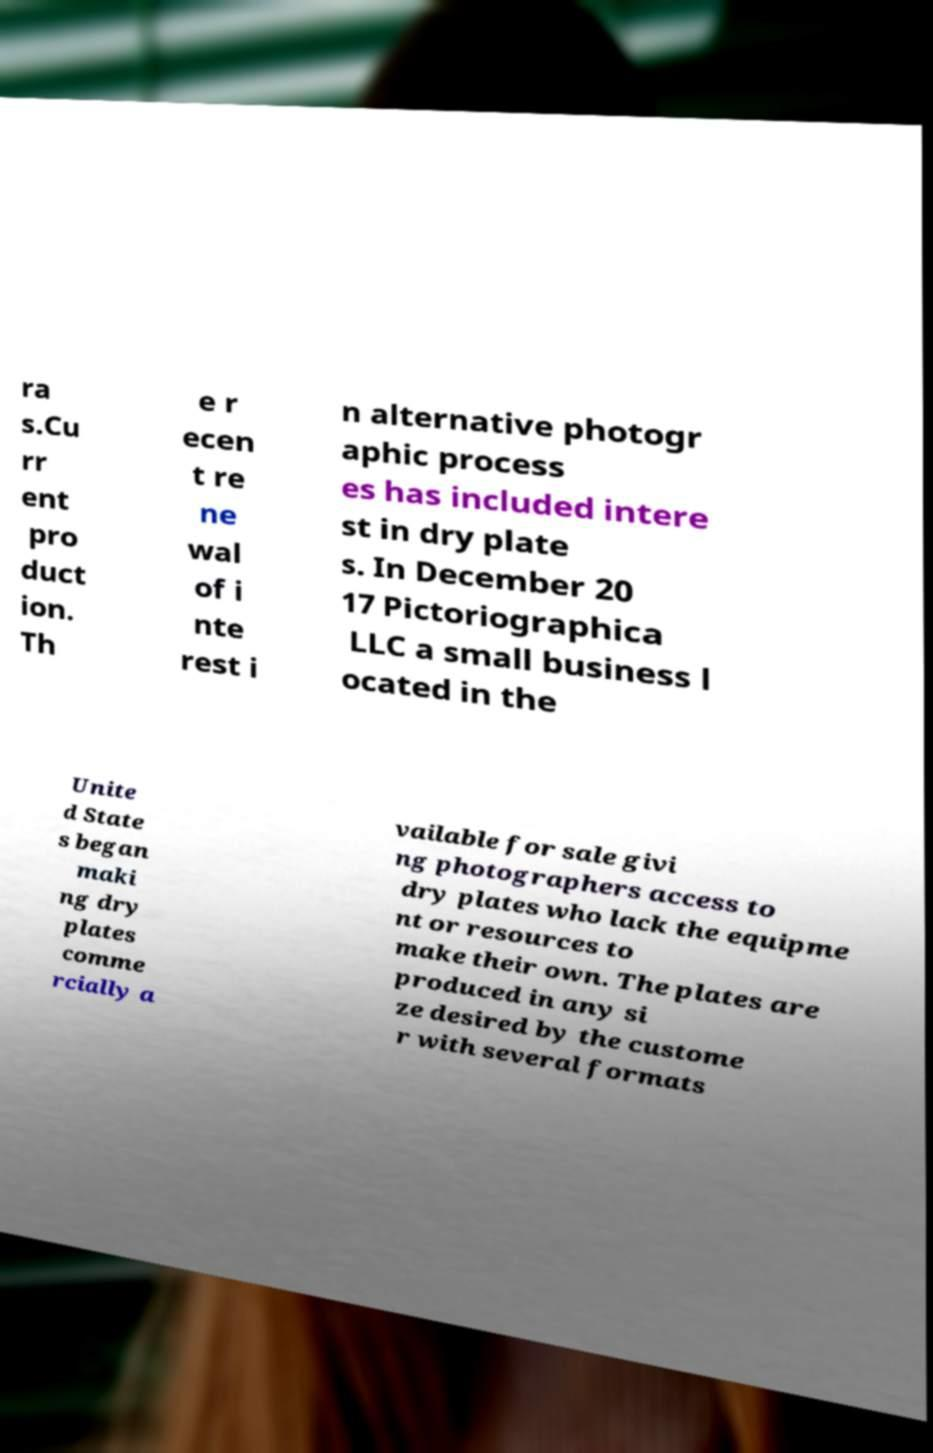Could you assist in decoding the text presented in this image and type it out clearly? ra s.Cu rr ent pro duct ion. Th e r ecen t re ne wal of i nte rest i n alternative photogr aphic process es has included intere st in dry plate s. In December 20 17 Pictoriographica LLC a small business l ocated in the Unite d State s began maki ng dry plates comme rcially a vailable for sale givi ng photographers access to dry plates who lack the equipme nt or resources to make their own. The plates are produced in any si ze desired by the custome r with several formats 